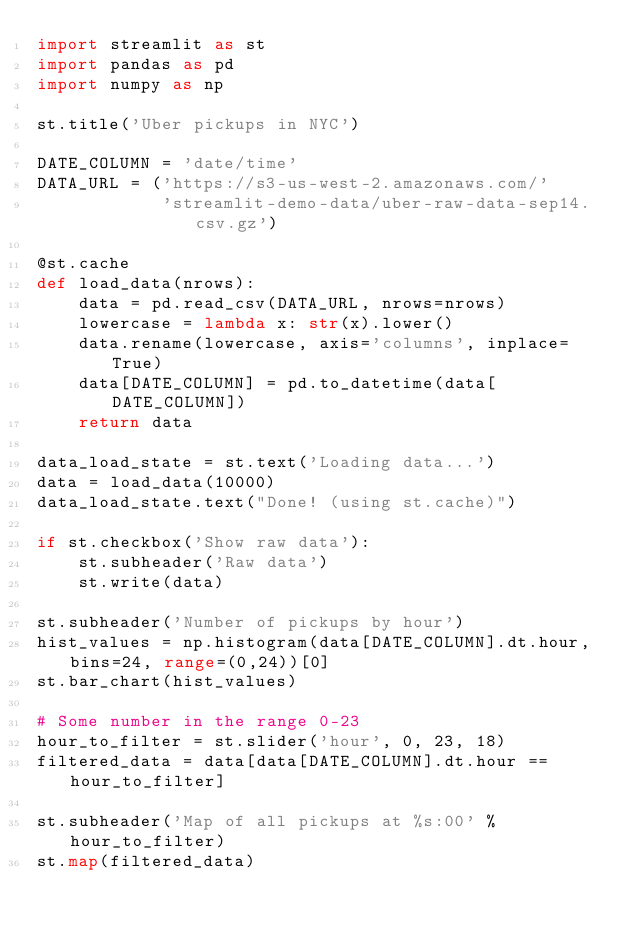Convert code to text. <code><loc_0><loc_0><loc_500><loc_500><_Python_>import streamlit as st
import pandas as pd
import numpy as np

st.title('Uber pickups in NYC')

DATE_COLUMN = 'date/time'
DATA_URL = ('https://s3-us-west-2.amazonaws.com/'
            'streamlit-demo-data/uber-raw-data-sep14.csv.gz')

@st.cache
def load_data(nrows):
    data = pd.read_csv(DATA_URL, nrows=nrows)
    lowercase = lambda x: str(x).lower()
    data.rename(lowercase, axis='columns', inplace=True)
    data[DATE_COLUMN] = pd.to_datetime(data[DATE_COLUMN])
    return data

data_load_state = st.text('Loading data...')
data = load_data(10000)
data_load_state.text("Done! (using st.cache)")

if st.checkbox('Show raw data'):
    st.subheader('Raw data')
    st.write(data)

st.subheader('Number of pickups by hour')
hist_values = np.histogram(data[DATE_COLUMN].dt.hour, bins=24, range=(0,24))[0]
st.bar_chart(hist_values)

# Some number in the range 0-23
hour_to_filter = st.slider('hour', 0, 23, 18)
filtered_data = data[data[DATE_COLUMN].dt.hour == hour_to_filter]

st.subheader('Map of all pickups at %s:00' % hour_to_filter)
st.map(filtered_data)
</code> 